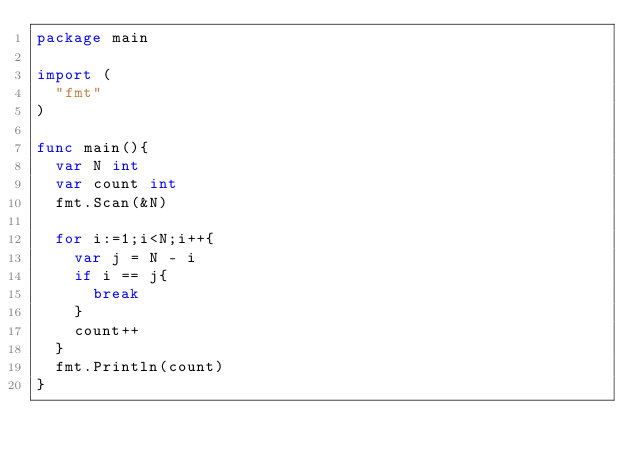<code> <loc_0><loc_0><loc_500><loc_500><_Go_>package main
 
import (
  "fmt"
)
 
func main(){
  var N int
  var count int
  fmt.Scan(&N)
  
  for i:=1;i<N;i++{
    var j = N - i
    if i == j{
      break
    }
    count++
  }
  fmt.Println(count)
}</code> 